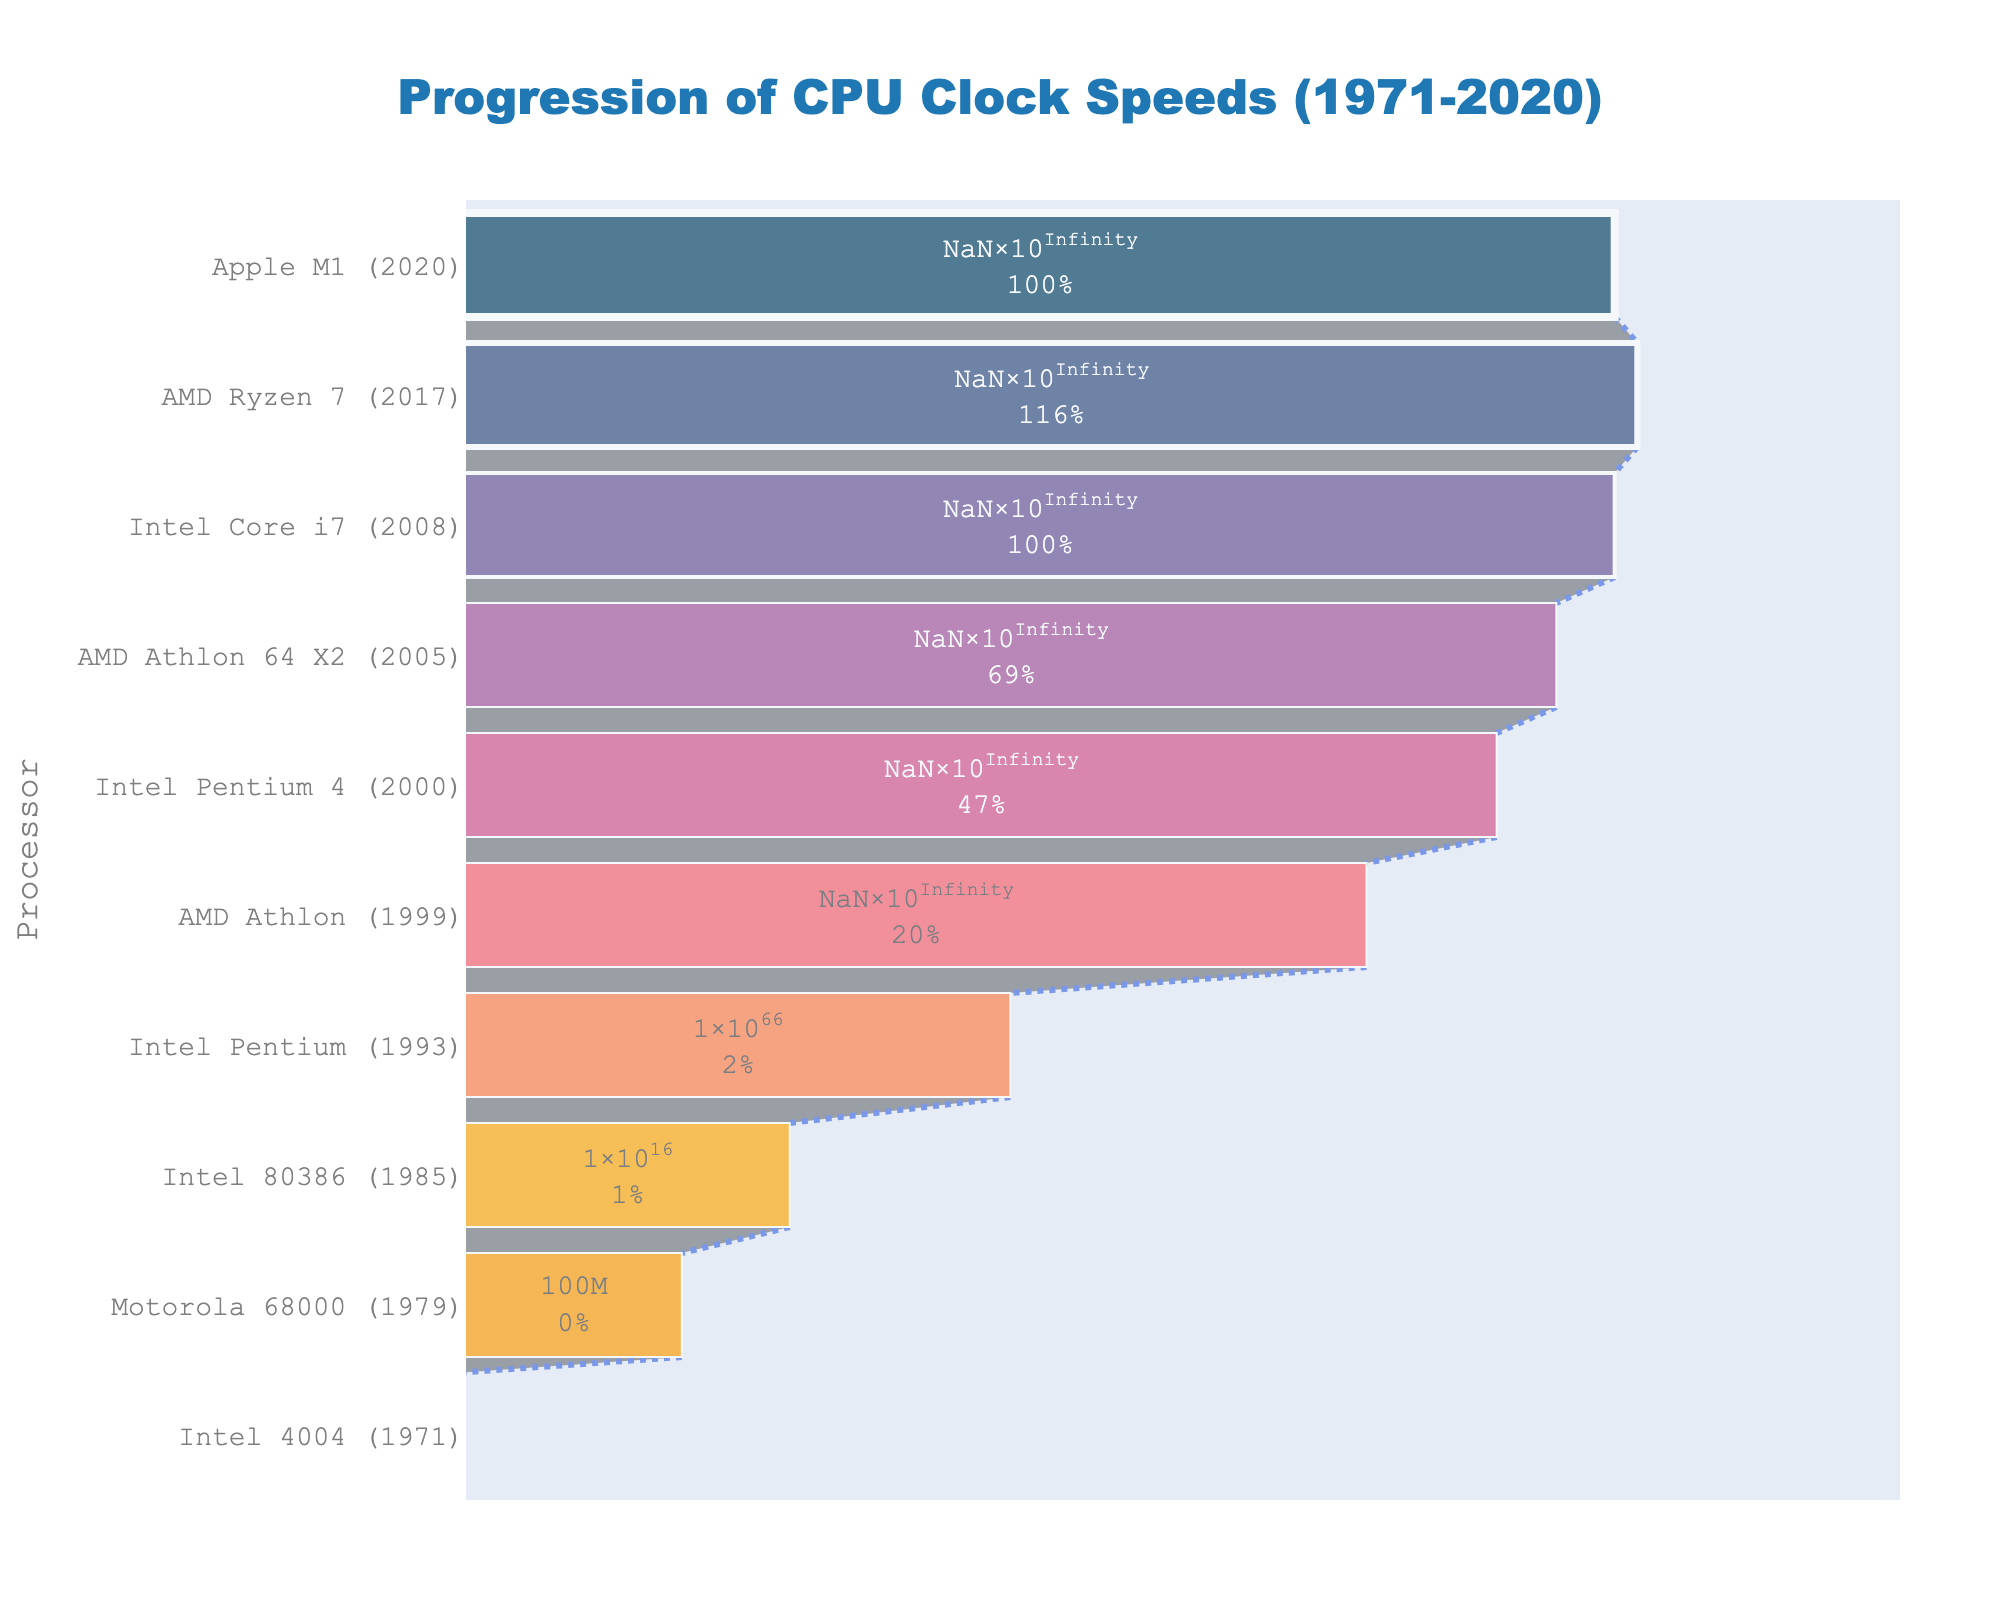what is the title of the figure? The title is displayed prominently at the top of the figure. It reads "Progression of CPU Clock Speeds (1971-2020)."
Answer: Progression of CPU Clock Speeds (1971-2020) How many processors are listed in the figure? By counting the different stages listed along the y-axis, you can identify 10 processors from the Intel 4004 to the Apple M1.
Answer: 10 Which processor has the highest clock speed? The funnel chart visually emphasizes the highest value at the top. The AMD Ryzen 7 (2017) shows the highest clock speed of 3700 MHz.
Answer: AMD Ryzen 7 (2017) What was the clock speed of the Intel 80386 processor? The Intel 80386 processor, listed around the middle of the funnel, shows a clock speed of 16 MHz.
Answer: 16 MHz How much did the clock speed increase from the Intel 4004 to the Intel 80386 processor? The clock speed for the Intel 4004 is 0.74 MHz, and for the Intel 80386, it is 16 MHz. The increment is found by subtracting 0.74 from 16.
Answer: 15.26 MHz By what factor is the clock speed of the Intel Core i7 faster than that of the Motorola 68000? The clock speed of the Intel Core i7 is 3200 MHz, and for the Motorola 68000, it is 8 MHz. The factor is calculated by dividing 3200 by 8.
Answer: 400 Which processors have nearly identical clock speeds, and what are those speeds? The funnel chart shows both the Intel Core i7 (2008) and Apple M1 (2020) have clock speeds of 3200 MHz.
Answer: Intel Core i7 and Apple M1, 3200 MHz Which decade saw the largest increase in clock speed among the listed processors? The processors show significant jumps in clock speeds in various decades. The largest jump (from 66 MHz to 650 MHz) occurs between the Intel Pentium in 1993 and the AMD Athlon in 1999.
Answer: 1990s How does the clock speed progression trend visually appear in this funnel chart? The width of the funnel at each stage represents the clock speed, generally widening as it ascends, indicating an overall increase in CPU clock speeds over time.
Answer: Increasing trend 